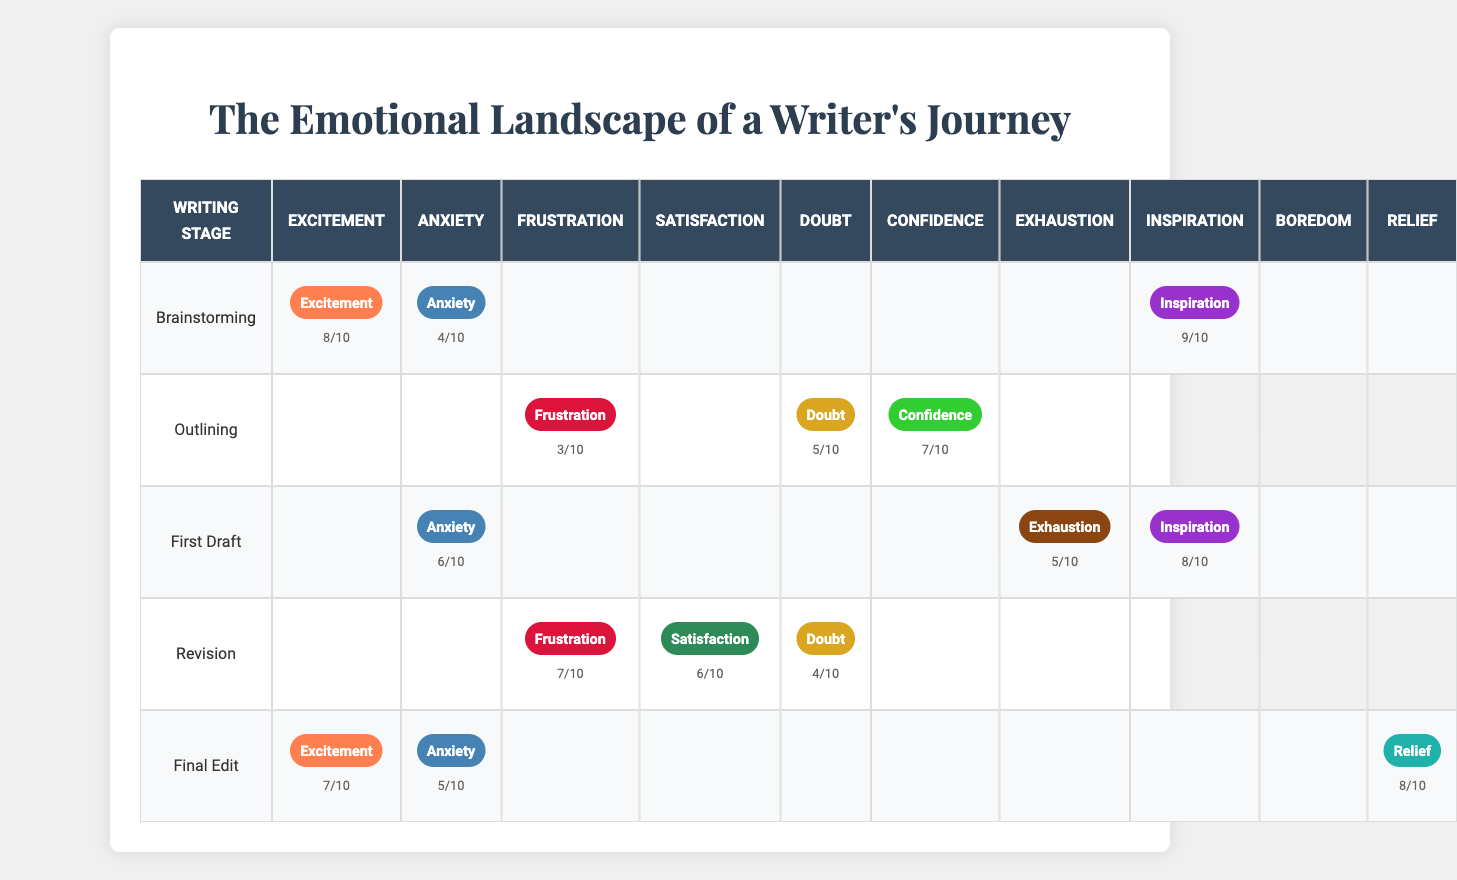What emotional state has the highest intensity in the First Draft stage? In the First Draft stage, the emotional states recorded are Anxiety (6), Inspiration (8), and Exhaustion (5). The highest intensity is from Inspiration with an intensity of 8.
Answer: Inspiration During which stage does the writer experience the most Frustration? The Frustration intensity is recorded as 3 in Outlining, 7 in Revision, and not mentioned in other stages. The highest intensity level is 7 in the Revision stage.
Answer: Revision What is the overall average intensity of Anxiety across all stages? The intensity of Anxiety is 4 in Brainstorming, 6 in First Draft, and 5 in Final Edit. To find the average, we sum these values (4 + 6 + 5 = 15) and divide by the number of stages (15 / 3 = 5).
Answer: 5 Is there any stage where Confidence is recorded as the highest emotional state? Confidence has an intensity of 7 in the Outlining stage. The other recorded emotions in that stage are Doubt (5) and Frustration (3), meaning Confidence is the highest in that specific stage as there is no other value above 7 in any stage.
Answer: Yes Which emotional state has the lowest intensity during the Outlining stage? In the Outlining stage, the emotional states are Confidence (7), Doubt (5), and Frustration (3). The lowest intensity of these states is Frustration at 3.
Answer: Frustration How does the intensity of Relief in the Final Edit stage compare to the intensity of Inspiration in the First Draft? The intensity of Relief in the Final Edit stage is 8, while Inspiration in the First Draft stage has an intensity of 8. The two intensities are equal when compared directly.
Answer: Equal What stage has the emotional state with the second highest intensity of Excitement? In the stages, Excitement appears in Brainstorming (8) and Final Edit (7). The second highest intensity is in the Final Edit stage, which has 7.
Answer: Final Edit Is the intensity of Exhaustion greater in the First Draft stage compared to any other stage? The intensity of Exhaustion is 5 in First Draft, and it does not appear in other stages. This is the only stage where it is recorded, so there is no point of comparison to determine if it is greater.
Answer: Yes What emotional states appear with an intensity score of 6 or higher in the Revision stage? In the Revision stage, the recorded emotional states are Frustration (7), Satisfaction (6), and Doubt (4). Both Frustration and Satisfaction have intensities of 6 or higher.
Answer: Frustration and Satisfaction Calculate the sum of intensities for the emotional states of Excitement in all stages combined. Excitement appears in Brainstorming (8) and Final Edit (7). The sum of these intensities is (8 + 7 = 15).
Answer: 15 